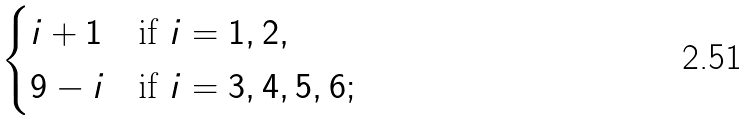Convert formula to latex. <formula><loc_0><loc_0><loc_500><loc_500>\begin{cases} i + 1 & \text {if } i = 1 , 2 , \\ 9 - i & \text {if } i = 3 , 4 , 5 , 6 ; \end{cases}</formula> 